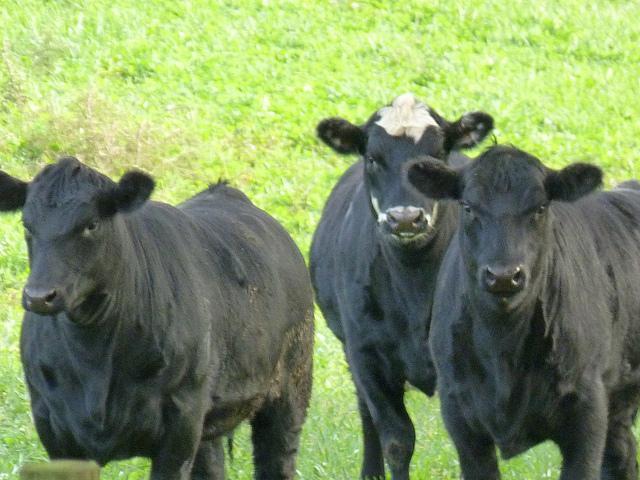What color is on the animal in the middle's head?
Indicate the correct choice and explain in the format: 'Answer: answer
Rationale: rationale.'
Options: Green, red, blue, white. Answer: white.
Rationale: Black and white cows are standing together in a pasture. How many black cows are standing up in the middle of the pasture?
Choose the correct response, then elucidate: 'Answer: answer
Rationale: rationale.'
Options: Four, two, five, three. Answer: three.
Rationale: There are 3. 